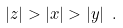Convert formula to latex. <formula><loc_0><loc_0><loc_500><loc_500>| z | > | x | > | y | \ .</formula> 